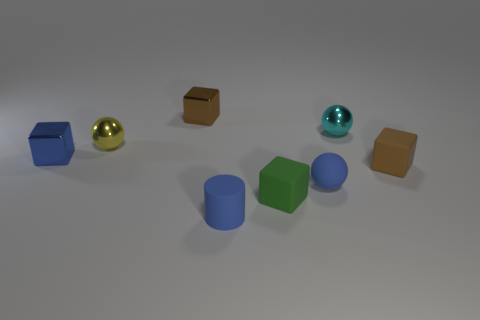Do the small yellow thing and the tiny cyan metal object have the same shape?
Make the answer very short. Yes. What number of spheres are tiny blue rubber things or brown objects?
Offer a very short reply. 1. The ball that is the same material as the tiny cylinder is what color?
Provide a short and direct response. Blue. There is a brown cube in front of the blue metal thing; is its size the same as the rubber cylinder?
Keep it short and to the point. Yes. Are the tiny green block and the sphere that is to the left of the small blue rubber cylinder made of the same material?
Ensure brevity in your answer.  No. There is a shiny ball on the left side of the tiny cyan shiny sphere; what color is it?
Keep it short and to the point. Yellow. There is a matte ball in front of the small brown metal thing; are there any tiny brown rubber blocks that are in front of it?
Keep it short and to the point. No. Does the tiny shiny sphere to the left of the tiny cylinder have the same color as the metal thing in front of the tiny yellow thing?
Keep it short and to the point. No. What number of rubber blocks are in front of the blue cylinder?
Provide a succinct answer. 0. How many tiny objects have the same color as the small cylinder?
Ensure brevity in your answer.  2. 